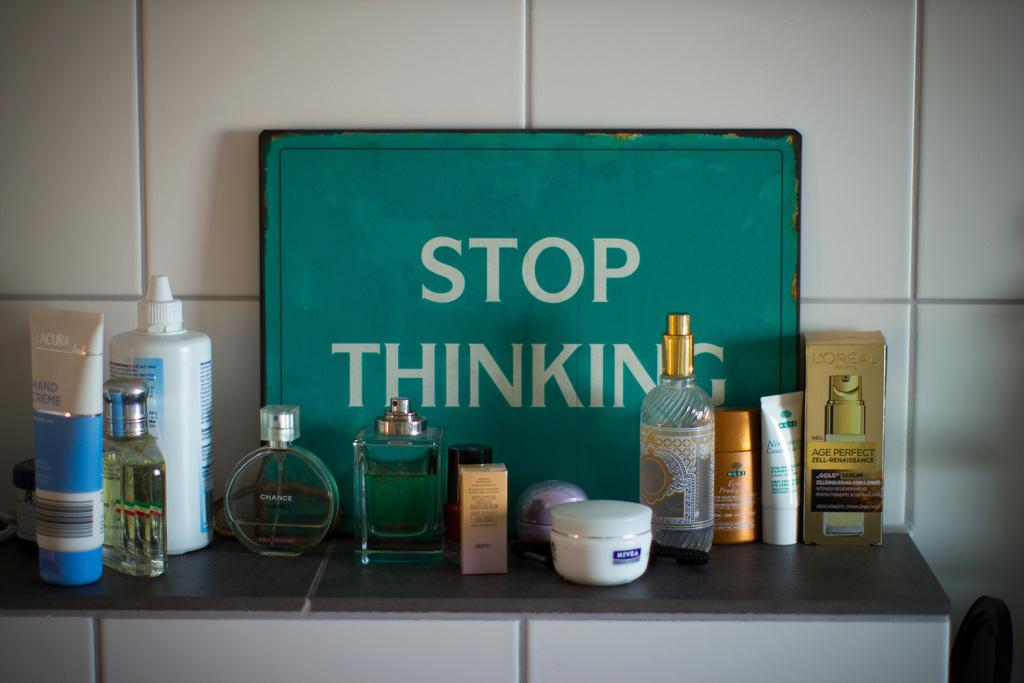<image>
Share a concise interpretation of the image provided. A number of toiletries stand on a tiled surface in front of a sign that says stop thinking. 